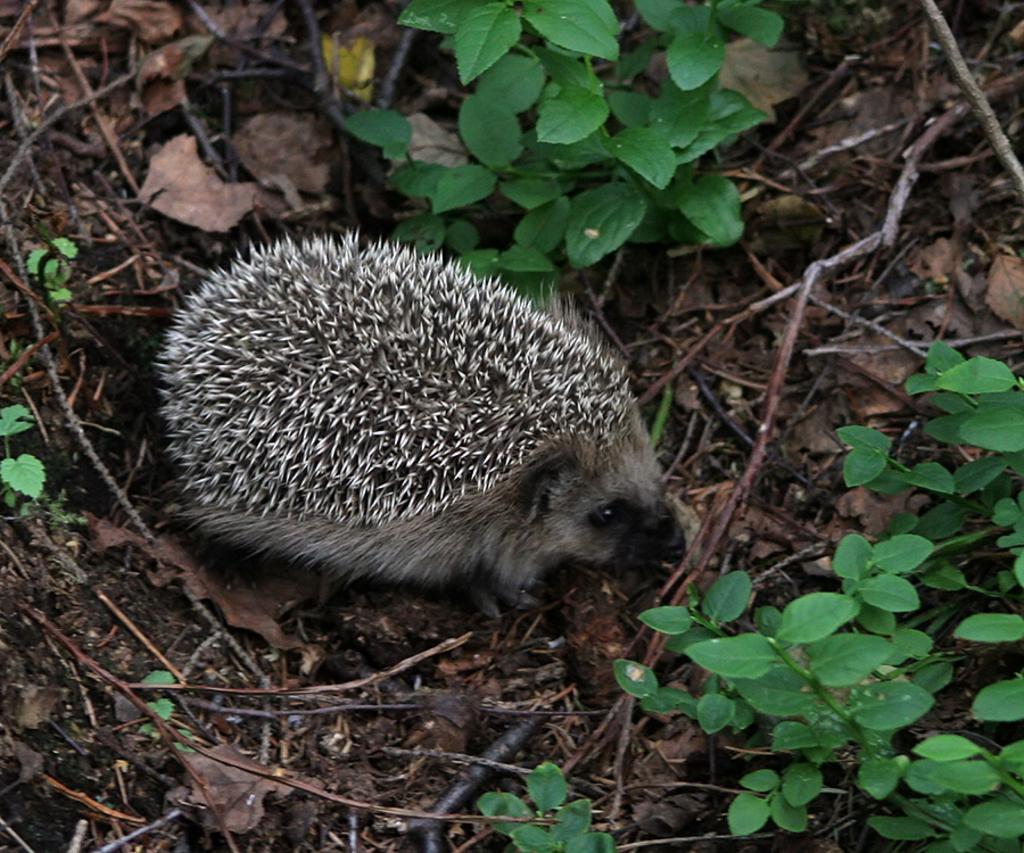Please provide a concise description of this image. In this image we can see porcupine on the ground. At the top of the image we can see a plant. 